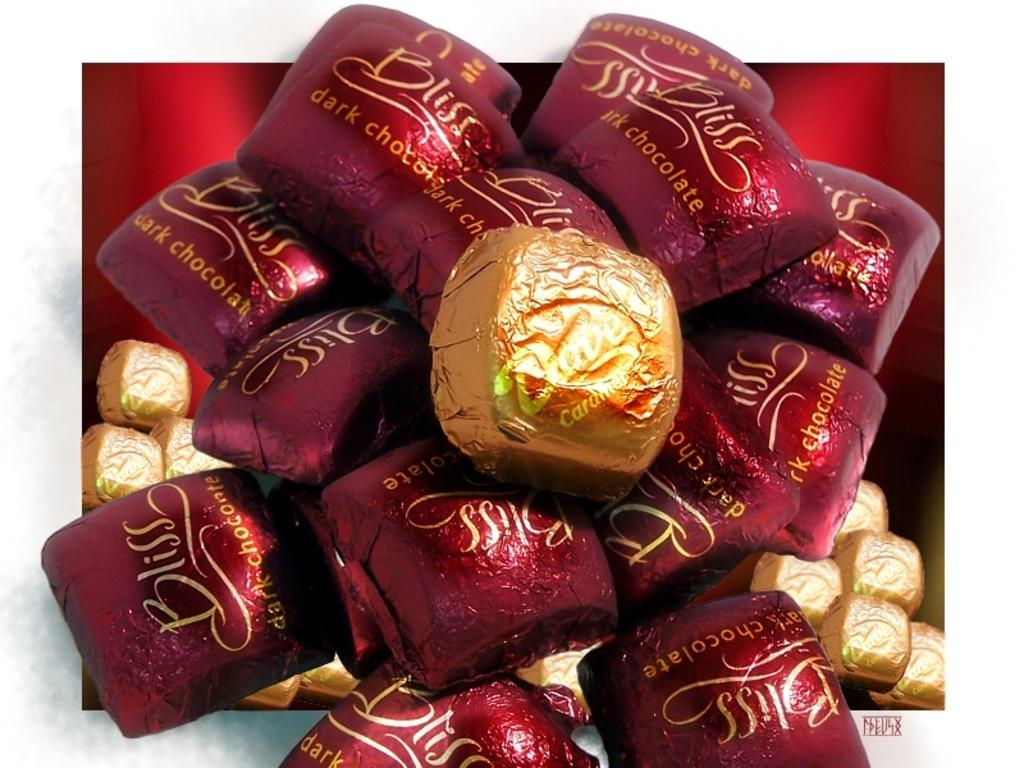What type of food is visible in the image? There is a bunch of chocolates in the image. How are the chocolates packaged? The chocolates are wrapped in wrappers. What else can be seen related to chocolates in the image? There is a chocolate box in the image. Can you describe the arrangement of the chocolates and the box in the image? The bunch of chocolates is above the chocolate box. What type of secretary can be seen working in the image? There is no secretary present in the image; it features a bunch of chocolates, wrapped chocolates, a chocolate box, and their arrangement. 